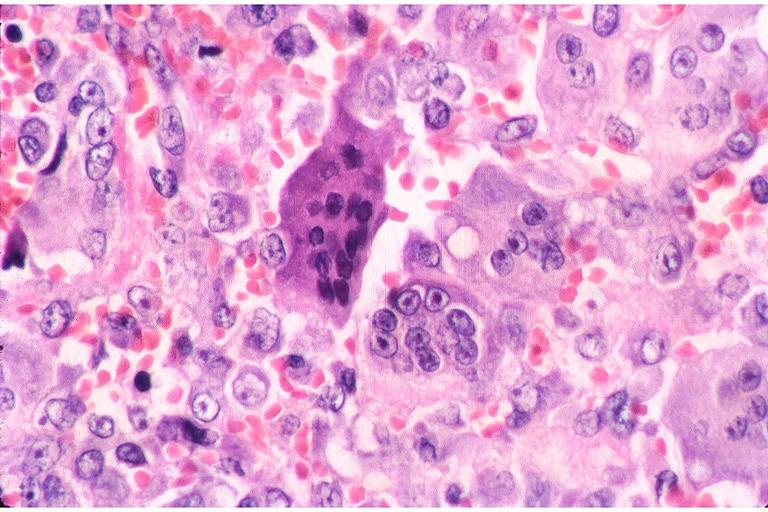s supernumerary digits present?
Answer the question using a single word or phrase. No 